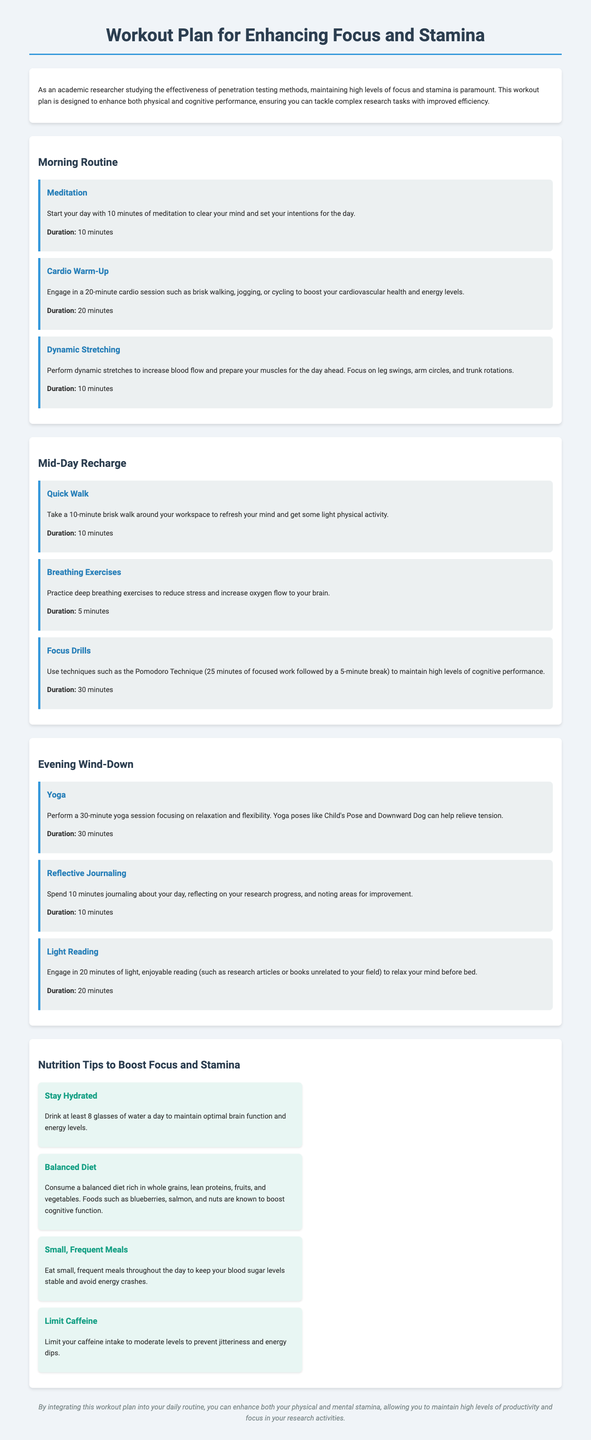what is the first exercise in the morning routine? The first exercise listed is Meditation, which is meant to clear the mind and set intentions.
Answer: Meditation how long should the cardio warm-up last? The document states that the cardio warm-up should last for 20 minutes.
Answer: 20 minutes what breathing technique is suggested during the mid-day recharge? The document suggests practicing deep breathing exercises to reduce stress and increase oxygen flow to the brain.
Answer: deep breathing exercises how long is the yoga session in the evening? According to the document, the yoga session should last for 30 minutes.
Answer: 30 minutes what type of meals are recommended for boosting focus and stamina? The document recommends small, frequent meals throughout the day to keep blood sugar levels stable.
Answer: small, frequent meals which food is mentioned as a cognitive booster? The document mentions blueberries, salmon, and nuts as foods known to boost cognitive function.
Answer: blueberries, salmon, and nuts what hydration advice is given? The document advises drinking at least 8 glasses of water a day for optimal brain function and energy levels.
Answer: 8 glasses of water what is the total duration for the mid-day recharge activities? The combined duration of the activities in the mid-day recharge section is 45 minutes (10 minutes + 5 minutes + 30 minutes).
Answer: 45 minutes what is the main goal of this workout plan? The main goal of the workout plan is to enhance both physical and cognitive performance for improved research productivity.
Answer: enhance both physical and cognitive performance 